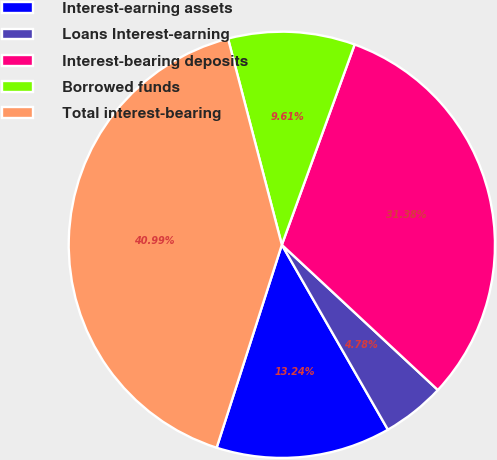Convert chart to OTSL. <chart><loc_0><loc_0><loc_500><loc_500><pie_chart><fcel>Interest-earning assets<fcel>Loans Interest-earning<fcel>Interest-bearing deposits<fcel>Borrowed funds<fcel>Total interest-bearing<nl><fcel>13.24%<fcel>4.78%<fcel>31.38%<fcel>9.61%<fcel>40.99%<nl></chart> 